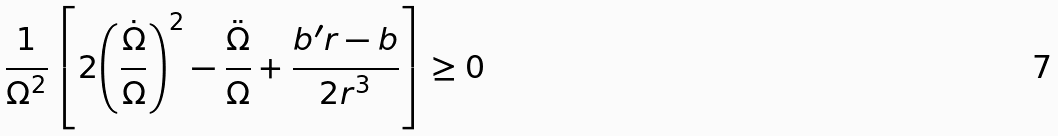Convert formula to latex. <formula><loc_0><loc_0><loc_500><loc_500>\frac { 1 } { \Omega ^ { 2 } } \left [ 2 { \left ( \frac { \dot { \Omega } } { \Omega } \right ) } ^ { 2 } - \frac { \ddot { \Omega } } { \Omega } + \frac { b ^ { \prime } r - b } { 2 r ^ { 3 } } \right ] \geq 0</formula> 